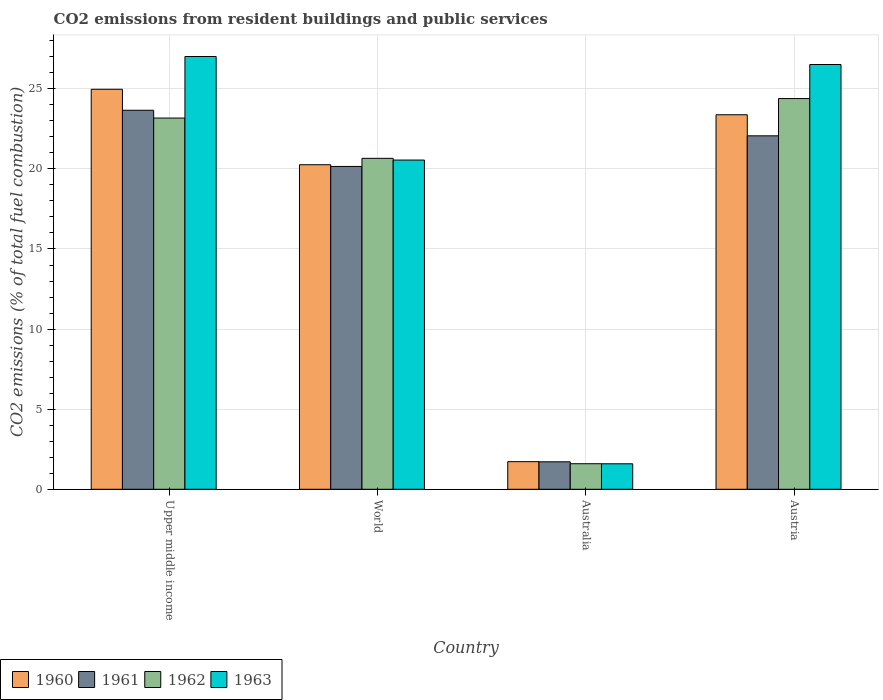Are the number of bars per tick equal to the number of legend labels?
Ensure brevity in your answer.  Yes. Are the number of bars on each tick of the X-axis equal?
Your response must be concise. Yes. How many bars are there on the 1st tick from the left?
Provide a short and direct response. 4. How many bars are there on the 4th tick from the right?
Offer a very short reply. 4. What is the label of the 1st group of bars from the left?
Provide a short and direct response. Upper middle income. What is the total CO2 emitted in 1960 in Austria?
Keep it short and to the point. 23.38. Across all countries, what is the maximum total CO2 emitted in 1963?
Offer a terse response. 27.01. Across all countries, what is the minimum total CO2 emitted in 1963?
Provide a short and direct response. 1.59. In which country was the total CO2 emitted in 1962 maximum?
Your answer should be compact. Austria. What is the total total CO2 emitted in 1962 in the graph?
Make the answer very short. 69.82. What is the difference between the total CO2 emitted in 1963 in Austria and that in World?
Provide a short and direct response. 5.96. What is the difference between the total CO2 emitted in 1963 in Austria and the total CO2 emitted in 1962 in Upper middle income?
Give a very brief answer. 3.34. What is the average total CO2 emitted in 1961 per country?
Your answer should be compact. 16.9. What is the difference between the total CO2 emitted of/in 1962 and total CO2 emitted of/in 1960 in Upper middle income?
Your answer should be compact. -1.8. In how many countries, is the total CO2 emitted in 1962 greater than 25?
Give a very brief answer. 0. What is the ratio of the total CO2 emitted in 1961 in Austria to that in World?
Give a very brief answer. 1.09. Is the total CO2 emitted in 1962 in Austria less than that in World?
Your response must be concise. No. What is the difference between the highest and the second highest total CO2 emitted in 1963?
Provide a short and direct response. -0.5. What is the difference between the highest and the lowest total CO2 emitted in 1961?
Your answer should be very brief. 21.95. Is the sum of the total CO2 emitted in 1960 in Upper middle income and World greater than the maximum total CO2 emitted in 1963 across all countries?
Your answer should be compact. Yes. How many bars are there?
Your answer should be compact. 16. What is the difference between two consecutive major ticks on the Y-axis?
Offer a terse response. 5. Does the graph contain any zero values?
Your answer should be very brief. No. What is the title of the graph?
Your response must be concise. CO2 emissions from resident buildings and public services. Does "2011" appear as one of the legend labels in the graph?
Make the answer very short. No. What is the label or title of the X-axis?
Give a very brief answer. Country. What is the label or title of the Y-axis?
Offer a terse response. CO2 emissions (% of total fuel combustion). What is the CO2 emissions (% of total fuel combustion) of 1960 in Upper middle income?
Keep it short and to the point. 24.97. What is the CO2 emissions (% of total fuel combustion) of 1961 in Upper middle income?
Offer a very short reply. 23.66. What is the CO2 emissions (% of total fuel combustion) of 1962 in Upper middle income?
Keep it short and to the point. 23.17. What is the CO2 emissions (% of total fuel combustion) in 1963 in Upper middle income?
Give a very brief answer. 27.01. What is the CO2 emissions (% of total fuel combustion) of 1960 in World?
Provide a succinct answer. 20.26. What is the CO2 emissions (% of total fuel combustion) of 1961 in World?
Make the answer very short. 20.15. What is the CO2 emissions (% of total fuel combustion) in 1962 in World?
Your answer should be compact. 20.66. What is the CO2 emissions (% of total fuel combustion) in 1963 in World?
Your answer should be very brief. 20.55. What is the CO2 emissions (% of total fuel combustion) of 1960 in Australia?
Offer a terse response. 1.72. What is the CO2 emissions (% of total fuel combustion) of 1961 in Australia?
Give a very brief answer. 1.71. What is the CO2 emissions (% of total fuel combustion) of 1962 in Australia?
Offer a very short reply. 1.59. What is the CO2 emissions (% of total fuel combustion) of 1963 in Australia?
Your answer should be very brief. 1.59. What is the CO2 emissions (% of total fuel combustion) in 1960 in Austria?
Give a very brief answer. 23.38. What is the CO2 emissions (% of total fuel combustion) of 1961 in Austria?
Provide a succinct answer. 22.06. What is the CO2 emissions (% of total fuel combustion) in 1962 in Austria?
Your response must be concise. 24.39. What is the CO2 emissions (% of total fuel combustion) of 1963 in Austria?
Give a very brief answer. 26.52. Across all countries, what is the maximum CO2 emissions (% of total fuel combustion) of 1960?
Offer a very short reply. 24.97. Across all countries, what is the maximum CO2 emissions (% of total fuel combustion) in 1961?
Give a very brief answer. 23.66. Across all countries, what is the maximum CO2 emissions (% of total fuel combustion) of 1962?
Offer a very short reply. 24.39. Across all countries, what is the maximum CO2 emissions (% of total fuel combustion) of 1963?
Offer a terse response. 27.01. Across all countries, what is the minimum CO2 emissions (% of total fuel combustion) of 1960?
Give a very brief answer. 1.72. Across all countries, what is the minimum CO2 emissions (% of total fuel combustion) of 1961?
Keep it short and to the point. 1.71. Across all countries, what is the minimum CO2 emissions (% of total fuel combustion) of 1962?
Your answer should be compact. 1.59. Across all countries, what is the minimum CO2 emissions (% of total fuel combustion) in 1963?
Offer a very short reply. 1.59. What is the total CO2 emissions (% of total fuel combustion) in 1960 in the graph?
Provide a short and direct response. 70.33. What is the total CO2 emissions (% of total fuel combustion) of 1961 in the graph?
Keep it short and to the point. 67.59. What is the total CO2 emissions (% of total fuel combustion) in 1962 in the graph?
Ensure brevity in your answer.  69.82. What is the total CO2 emissions (% of total fuel combustion) of 1963 in the graph?
Ensure brevity in your answer.  75.67. What is the difference between the CO2 emissions (% of total fuel combustion) in 1960 in Upper middle income and that in World?
Give a very brief answer. 4.71. What is the difference between the CO2 emissions (% of total fuel combustion) in 1961 in Upper middle income and that in World?
Offer a very short reply. 3.51. What is the difference between the CO2 emissions (% of total fuel combustion) in 1962 in Upper middle income and that in World?
Offer a terse response. 2.52. What is the difference between the CO2 emissions (% of total fuel combustion) of 1963 in Upper middle income and that in World?
Your answer should be compact. 6.46. What is the difference between the CO2 emissions (% of total fuel combustion) in 1960 in Upper middle income and that in Australia?
Make the answer very short. 23.25. What is the difference between the CO2 emissions (% of total fuel combustion) in 1961 in Upper middle income and that in Australia?
Provide a short and direct response. 21.95. What is the difference between the CO2 emissions (% of total fuel combustion) in 1962 in Upper middle income and that in Australia?
Your answer should be compact. 21.58. What is the difference between the CO2 emissions (% of total fuel combustion) in 1963 in Upper middle income and that in Australia?
Your answer should be compact. 25.42. What is the difference between the CO2 emissions (% of total fuel combustion) in 1960 in Upper middle income and that in Austria?
Your response must be concise. 1.59. What is the difference between the CO2 emissions (% of total fuel combustion) in 1961 in Upper middle income and that in Austria?
Provide a succinct answer. 1.6. What is the difference between the CO2 emissions (% of total fuel combustion) of 1962 in Upper middle income and that in Austria?
Make the answer very short. -1.22. What is the difference between the CO2 emissions (% of total fuel combustion) in 1963 in Upper middle income and that in Austria?
Your answer should be compact. 0.5. What is the difference between the CO2 emissions (% of total fuel combustion) of 1960 in World and that in Australia?
Ensure brevity in your answer.  18.54. What is the difference between the CO2 emissions (% of total fuel combustion) of 1961 in World and that in Australia?
Your answer should be compact. 18.44. What is the difference between the CO2 emissions (% of total fuel combustion) of 1962 in World and that in Australia?
Your response must be concise. 19.06. What is the difference between the CO2 emissions (% of total fuel combustion) in 1963 in World and that in Australia?
Your answer should be compact. 18.96. What is the difference between the CO2 emissions (% of total fuel combustion) in 1960 in World and that in Austria?
Your response must be concise. -3.12. What is the difference between the CO2 emissions (% of total fuel combustion) of 1961 in World and that in Austria?
Provide a short and direct response. -1.91. What is the difference between the CO2 emissions (% of total fuel combustion) in 1962 in World and that in Austria?
Provide a succinct answer. -3.73. What is the difference between the CO2 emissions (% of total fuel combustion) of 1963 in World and that in Austria?
Your response must be concise. -5.96. What is the difference between the CO2 emissions (% of total fuel combustion) in 1960 in Australia and that in Austria?
Ensure brevity in your answer.  -21.65. What is the difference between the CO2 emissions (% of total fuel combustion) of 1961 in Australia and that in Austria?
Give a very brief answer. -20.35. What is the difference between the CO2 emissions (% of total fuel combustion) in 1962 in Australia and that in Austria?
Provide a succinct answer. -22.8. What is the difference between the CO2 emissions (% of total fuel combustion) of 1963 in Australia and that in Austria?
Give a very brief answer. -24.92. What is the difference between the CO2 emissions (% of total fuel combustion) in 1960 in Upper middle income and the CO2 emissions (% of total fuel combustion) in 1961 in World?
Your answer should be very brief. 4.82. What is the difference between the CO2 emissions (% of total fuel combustion) in 1960 in Upper middle income and the CO2 emissions (% of total fuel combustion) in 1962 in World?
Your response must be concise. 4.31. What is the difference between the CO2 emissions (% of total fuel combustion) in 1960 in Upper middle income and the CO2 emissions (% of total fuel combustion) in 1963 in World?
Offer a very short reply. 4.42. What is the difference between the CO2 emissions (% of total fuel combustion) in 1961 in Upper middle income and the CO2 emissions (% of total fuel combustion) in 1962 in World?
Make the answer very short. 3. What is the difference between the CO2 emissions (% of total fuel combustion) in 1961 in Upper middle income and the CO2 emissions (% of total fuel combustion) in 1963 in World?
Ensure brevity in your answer.  3.11. What is the difference between the CO2 emissions (% of total fuel combustion) of 1962 in Upper middle income and the CO2 emissions (% of total fuel combustion) of 1963 in World?
Make the answer very short. 2.62. What is the difference between the CO2 emissions (% of total fuel combustion) of 1960 in Upper middle income and the CO2 emissions (% of total fuel combustion) of 1961 in Australia?
Ensure brevity in your answer.  23.26. What is the difference between the CO2 emissions (% of total fuel combustion) of 1960 in Upper middle income and the CO2 emissions (% of total fuel combustion) of 1962 in Australia?
Offer a terse response. 23.38. What is the difference between the CO2 emissions (% of total fuel combustion) in 1960 in Upper middle income and the CO2 emissions (% of total fuel combustion) in 1963 in Australia?
Offer a very short reply. 23.38. What is the difference between the CO2 emissions (% of total fuel combustion) in 1961 in Upper middle income and the CO2 emissions (% of total fuel combustion) in 1962 in Australia?
Offer a terse response. 22.07. What is the difference between the CO2 emissions (% of total fuel combustion) in 1961 in Upper middle income and the CO2 emissions (% of total fuel combustion) in 1963 in Australia?
Your answer should be very brief. 22.07. What is the difference between the CO2 emissions (% of total fuel combustion) of 1962 in Upper middle income and the CO2 emissions (% of total fuel combustion) of 1963 in Australia?
Ensure brevity in your answer.  21.58. What is the difference between the CO2 emissions (% of total fuel combustion) of 1960 in Upper middle income and the CO2 emissions (% of total fuel combustion) of 1961 in Austria?
Provide a succinct answer. 2.9. What is the difference between the CO2 emissions (% of total fuel combustion) in 1960 in Upper middle income and the CO2 emissions (% of total fuel combustion) in 1962 in Austria?
Make the answer very short. 0.58. What is the difference between the CO2 emissions (% of total fuel combustion) of 1960 in Upper middle income and the CO2 emissions (% of total fuel combustion) of 1963 in Austria?
Ensure brevity in your answer.  -1.55. What is the difference between the CO2 emissions (% of total fuel combustion) in 1961 in Upper middle income and the CO2 emissions (% of total fuel combustion) in 1962 in Austria?
Provide a short and direct response. -0.73. What is the difference between the CO2 emissions (% of total fuel combustion) in 1961 in Upper middle income and the CO2 emissions (% of total fuel combustion) in 1963 in Austria?
Provide a succinct answer. -2.86. What is the difference between the CO2 emissions (% of total fuel combustion) of 1962 in Upper middle income and the CO2 emissions (% of total fuel combustion) of 1963 in Austria?
Ensure brevity in your answer.  -3.34. What is the difference between the CO2 emissions (% of total fuel combustion) of 1960 in World and the CO2 emissions (% of total fuel combustion) of 1961 in Australia?
Keep it short and to the point. 18.55. What is the difference between the CO2 emissions (% of total fuel combustion) in 1960 in World and the CO2 emissions (% of total fuel combustion) in 1962 in Australia?
Provide a succinct answer. 18.67. What is the difference between the CO2 emissions (% of total fuel combustion) of 1960 in World and the CO2 emissions (% of total fuel combustion) of 1963 in Australia?
Provide a short and direct response. 18.67. What is the difference between the CO2 emissions (% of total fuel combustion) in 1961 in World and the CO2 emissions (% of total fuel combustion) in 1962 in Australia?
Make the answer very short. 18.56. What is the difference between the CO2 emissions (% of total fuel combustion) of 1961 in World and the CO2 emissions (% of total fuel combustion) of 1963 in Australia?
Provide a short and direct response. 18.56. What is the difference between the CO2 emissions (% of total fuel combustion) in 1962 in World and the CO2 emissions (% of total fuel combustion) in 1963 in Australia?
Your response must be concise. 19.07. What is the difference between the CO2 emissions (% of total fuel combustion) of 1960 in World and the CO2 emissions (% of total fuel combustion) of 1961 in Austria?
Your answer should be compact. -1.8. What is the difference between the CO2 emissions (% of total fuel combustion) in 1960 in World and the CO2 emissions (% of total fuel combustion) in 1962 in Austria?
Offer a very short reply. -4.13. What is the difference between the CO2 emissions (% of total fuel combustion) in 1960 in World and the CO2 emissions (% of total fuel combustion) in 1963 in Austria?
Make the answer very short. -6.26. What is the difference between the CO2 emissions (% of total fuel combustion) of 1961 in World and the CO2 emissions (% of total fuel combustion) of 1962 in Austria?
Make the answer very short. -4.24. What is the difference between the CO2 emissions (% of total fuel combustion) of 1961 in World and the CO2 emissions (% of total fuel combustion) of 1963 in Austria?
Provide a succinct answer. -6.36. What is the difference between the CO2 emissions (% of total fuel combustion) in 1962 in World and the CO2 emissions (% of total fuel combustion) in 1963 in Austria?
Give a very brief answer. -5.86. What is the difference between the CO2 emissions (% of total fuel combustion) of 1960 in Australia and the CO2 emissions (% of total fuel combustion) of 1961 in Austria?
Your answer should be very brief. -20.34. What is the difference between the CO2 emissions (% of total fuel combustion) in 1960 in Australia and the CO2 emissions (% of total fuel combustion) in 1962 in Austria?
Give a very brief answer. -22.67. What is the difference between the CO2 emissions (% of total fuel combustion) of 1960 in Australia and the CO2 emissions (% of total fuel combustion) of 1963 in Austria?
Provide a short and direct response. -24.79. What is the difference between the CO2 emissions (% of total fuel combustion) in 1961 in Australia and the CO2 emissions (% of total fuel combustion) in 1962 in Austria?
Your answer should be compact. -22.68. What is the difference between the CO2 emissions (% of total fuel combustion) in 1961 in Australia and the CO2 emissions (% of total fuel combustion) in 1963 in Austria?
Provide a succinct answer. -24.8. What is the difference between the CO2 emissions (% of total fuel combustion) in 1962 in Australia and the CO2 emissions (% of total fuel combustion) in 1963 in Austria?
Give a very brief answer. -24.92. What is the average CO2 emissions (% of total fuel combustion) of 1960 per country?
Your response must be concise. 17.58. What is the average CO2 emissions (% of total fuel combustion) of 1961 per country?
Your response must be concise. 16.9. What is the average CO2 emissions (% of total fuel combustion) of 1962 per country?
Provide a succinct answer. 17.45. What is the average CO2 emissions (% of total fuel combustion) in 1963 per country?
Your answer should be compact. 18.92. What is the difference between the CO2 emissions (% of total fuel combustion) in 1960 and CO2 emissions (% of total fuel combustion) in 1961 in Upper middle income?
Your answer should be very brief. 1.31. What is the difference between the CO2 emissions (% of total fuel combustion) in 1960 and CO2 emissions (% of total fuel combustion) in 1962 in Upper middle income?
Provide a short and direct response. 1.8. What is the difference between the CO2 emissions (% of total fuel combustion) in 1960 and CO2 emissions (% of total fuel combustion) in 1963 in Upper middle income?
Your response must be concise. -2.05. What is the difference between the CO2 emissions (% of total fuel combustion) in 1961 and CO2 emissions (% of total fuel combustion) in 1962 in Upper middle income?
Your response must be concise. 0.49. What is the difference between the CO2 emissions (% of total fuel combustion) of 1961 and CO2 emissions (% of total fuel combustion) of 1963 in Upper middle income?
Keep it short and to the point. -3.35. What is the difference between the CO2 emissions (% of total fuel combustion) of 1962 and CO2 emissions (% of total fuel combustion) of 1963 in Upper middle income?
Offer a terse response. -3.84. What is the difference between the CO2 emissions (% of total fuel combustion) of 1960 and CO2 emissions (% of total fuel combustion) of 1961 in World?
Offer a very short reply. 0.11. What is the difference between the CO2 emissions (% of total fuel combustion) of 1960 and CO2 emissions (% of total fuel combustion) of 1962 in World?
Ensure brevity in your answer.  -0.4. What is the difference between the CO2 emissions (% of total fuel combustion) in 1960 and CO2 emissions (% of total fuel combustion) in 1963 in World?
Ensure brevity in your answer.  -0.29. What is the difference between the CO2 emissions (% of total fuel combustion) in 1961 and CO2 emissions (% of total fuel combustion) in 1962 in World?
Give a very brief answer. -0.5. What is the difference between the CO2 emissions (% of total fuel combustion) in 1961 and CO2 emissions (% of total fuel combustion) in 1963 in World?
Provide a succinct answer. -0.4. What is the difference between the CO2 emissions (% of total fuel combustion) in 1962 and CO2 emissions (% of total fuel combustion) in 1963 in World?
Provide a short and direct response. 0.11. What is the difference between the CO2 emissions (% of total fuel combustion) in 1960 and CO2 emissions (% of total fuel combustion) in 1961 in Australia?
Ensure brevity in your answer.  0.01. What is the difference between the CO2 emissions (% of total fuel combustion) in 1960 and CO2 emissions (% of total fuel combustion) in 1962 in Australia?
Give a very brief answer. 0.13. What is the difference between the CO2 emissions (% of total fuel combustion) in 1960 and CO2 emissions (% of total fuel combustion) in 1963 in Australia?
Your answer should be very brief. 0.13. What is the difference between the CO2 emissions (% of total fuel combustion) of 1961 and CO2 emissions (% of total fuel combustion) of 1962 in Australia?
Offer a very short reply. 0.12. What is the difference between the CO2 emissions (% of total fuel combustion) in 1961 and CO2 emissions (% of total fuel combustion) in 1963 in Australia?
Your answer should be very brief. 0.12. What is the difference between the CO2 emissions (% of total fuel combustion) of 1962 and CO2 emissions (% of total fuel combustion) of 1963 in Australia?
Offer a terse response. 0. What is the difference between the CO2 emissions (% of total fuel combustion) of 1960 and CO2 emissions (% of total fuel combustion) of 1961 in Austria?
Provide a succinct answer. 1.31. What is the difference between the CO2 emissions (% of total fuel combustion) in 1960 and CO2 emissions (% of total fuel combustion) in 1962 in Austria?
Keep it short and to the point. -1.01. What is the difference between the CO2 emissions (% of total fuel combustion) in 1960 and CO2 emissions (% of total fuel combustion) in 1963 in Austria?
Offer a very short reply. -3.14. What is the difference between the CO2 emissions (% of total fuel combustion) in 1961 and CO2 emissions (% of total fuel combustion) in 1962 in Austria?
Make the answer very short. -2.33. What is the difference between the CO2 emissions (% of total fuel combustion) in 1961 and CO2 emissions (% of total fuel combustion) in 1963 in Austria?
Your answer should be compact. -4.45. What is the difference between the CO2 emissions (% of total fuel combustion) of 1962 and CO2 emissions (% of total fuel combustion) of 1963 in Austria?
Provide a short and direct response. -2.12. What is the ratio of the CO2 emissions (% of total fuel combustion) in 1960 in Upper middle income to that in World?
Ensure brevity in your answer.  1.23. What is the ratio of the CO2 emissions (% of total fuel combustion) in 1961 in Upper middle income to that in World?
Your response must be concise. 1.17. What is the ratio of the CO2 emissions (% of total fuel combustion) of 1962 in Upper middle income to that in World?
Your answer should be compact. 1.12. What is the ratio of the CO2 emissions (% of total fuel combustion) in 1963 in Upper middle income to that in World?
Keep it short and to the point. 1.31. What is the ratio of the CO2 emissions (% of total fuel combustion) in 1960 in Upper middle income to that in Australia?
Keep it short and to the point. 14.48. What is the ratio of the CO2 emissions (% of total fuel combustion) of 1961 in Upper middle income to that in Australia?
Provide a short and direct response. 13.8. What is the ratio of the CO2 emissions (% of total fuel combustion) in 1962 in Upper middle income to that in Australia?
Your answer should be very brief. 14.53. What is the ratio of the CO2 emissions (% of total fuel combustion) of 1963 in Upper middle income to that in Australia?
Offer a terse response. 16.98. What is the ratio of the CO2 emissions (% of total fuel combustion) of 1960 in Upper middle income to that in Austria?
Provide a succinct answer. 1.07. What is the ratio of the CO2 emissions (% of total fuel combustion) of 1961 in Upper middle income to that in Austria?
Offer a very short reply. 1.07. What is the ratio of the CO2 emissions (% of total fuel combustion) of 1962 in Upper middle income to that in Austria?
Your answer should be compact. 0.95. What is the ratio of the CO2 emissions (% of total fuel combustion) in 1963 in Upper middle income to that in Austria?
Offer a terse response. 1.02. What is the ratio of the CO2 emissions (% of total fuel combustion) in 1960 in World to that in Australia?
Your answer should be compact. 11.75. What is the ratio of the CO2 emissions (% of total fuel combustion) of 1961 in World to that in Australia?
Keep it short and to the point. 11.75. What is the ratio of the CO2 emissions (% of total fuel combustion) in 1962 in World to that in Australia?
Provide a succinct answer. 12.96. What is the ratio of the CO2 emissions (% of total fuel combustion) in 1963 in World to that in Australia?
Your answer should be very brief. 12.92. What is the ratio of the CO2 emissions (% of total fuel combustion) in 1960 in World to that in Austria?
Provide a short and direct response. 0.87. What is the ratio of the CO2 emissions (% of total fuel combustion) in 1961 in World to that in Austria?
Make the answer very short. 0.91. What is the ratio of the CO2 emissions (% of total fuel combustion) in 1962 in World to that in Austria?
Ensure brevity in your answer.  0.85. What is the ratio of the CO2 emissions (% of total fuel combustion) of 1963 in World to that in Austria?
Make the answer very short. 0.78. What is the ratio of the CO2 emissions (% of total fuel combustion) of 1960 in Australia to that in Austria?
Provide a short and direct response. 0.07. What is the ratio of the CO2 emissions (% of total fuel combustion) of 1961 in Australia to that in Austria?
Make the answer very short. 0.08. What is the ratio of the CO2 emissions (% of total fuel combustion) of 1962 in Australia to that in Austria?
Provide a short and direct response. 0.07. What is the difference between the highest and the second highest CO2 emissions (% of total fuel combustion) of 1960?
Provide a short and direct response. 1.59. What is the difference between the highest and the second highest CO2 emissions (% of total fuel combustion) of 1961?
Make the answer very short. 1.6. What is the difference between the highest and the second highest CO2 emissions (% of total fuel combustion) of 1962?
Offer a very short reply. 1.22. What is the difference between the highest and the second highest CO2 emissions (% of total fuel combustion) in 1963?
Make the answer very short. 0.5. What is the difference between the highest and the lowest CO2 emissions (% of total fuel combustion) in 1960?
Your response must be concise. 23.25. What is the difference between the highest and the lowest CO2 emissions (% of total fuel combustion) of 1961?
Provide a short and direct response. 21.95. What is the difference between the highest and the lowest CO2 emissions (% of total fuel combustion) in 1962?
Offer a very short reply. 22.8. What is the difference between the highest and the lowest CO2 emissions (% of total fuel combustion) in 1963?
Your answer should be very brief. 25.42. 